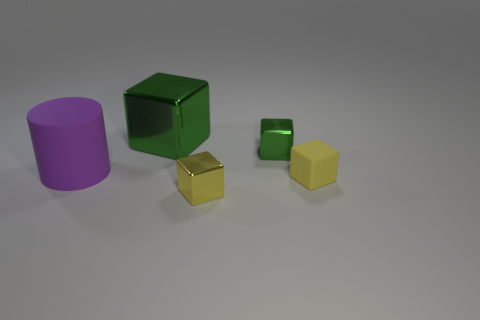Add 1 big purple cylinders. How many objects exist? 6 Subtract all cubes. How many objects are left? 1 Subtract 0 red cylinders. How many objects are left? 5 Subtract all big purple objects. Subtract all small yellow cubes. How many objects are left? 2 Add 5 purple rubber cylinders. How many purple rubber cylinders are left? 6 Add 3 tiny yellow matte blocks. How many tiny yellow matte blocks exist? 4 